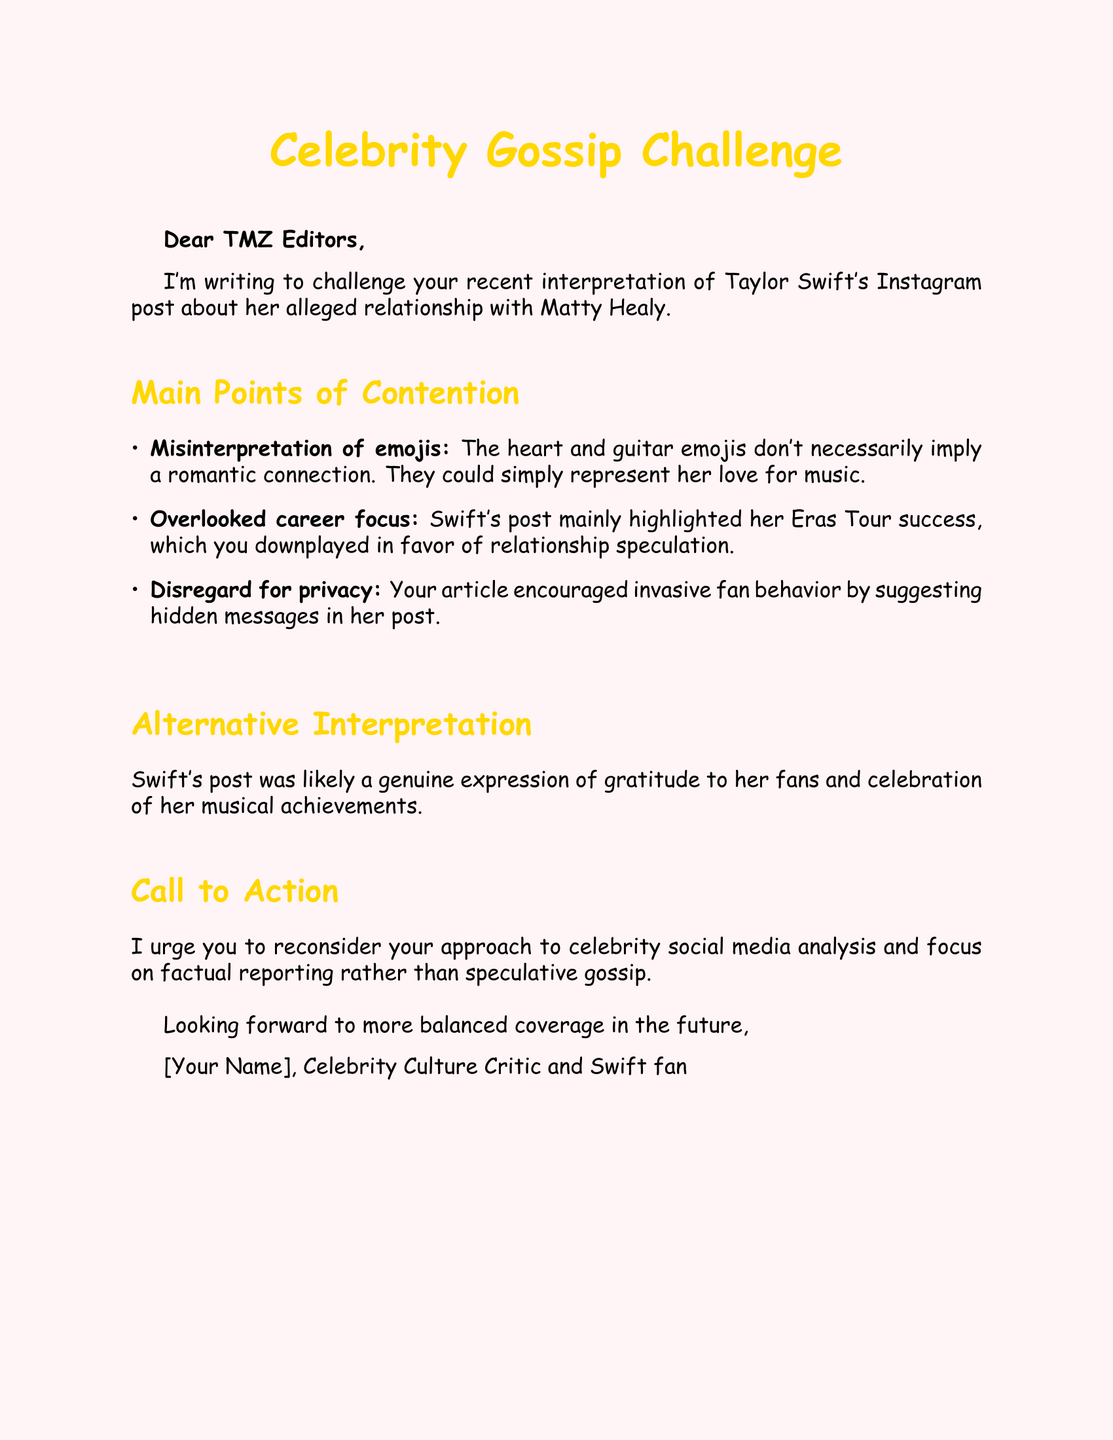What is the recipient's title? The title is addressed to "TMZ Editors" at the beginning of the document.
Answer: TMZ Editors What is the primary subject of the letter? The letter challenges the interpretation of Taylor Swift's Instagram post regarding her alleged relationship with Matty Healy.
Answer: Taylor Swift's Instagram post How many main points of contention are listed? There are three main points elaborated upon in the document.
Answer: 3 What does the fan letter urge the editors to reconsider? The letter calls for a reconsideration of their approach to celebrity social media analysis.
Answer: Their approach to celebrity social media analysis What emojis are referenced in the letter? The letter specifically mentions heart and guitar emojis in reference to their interpretation.
Answer: Heart and guitar emojis Which tour does the letter mention as a highlight in Swift's post? The Eras Tour is mentioned as the main focus of Swift's post.
Answer: Eras Tour What profession does the sender claim to have? The sender identifies themselves as a "Celebrity Culture Critic."
Answer: Celebrity Culture Critic What does the sender look forward to in the future? The sender expresses a desire for more balanced coverage.
Answer: More balanced coverage 